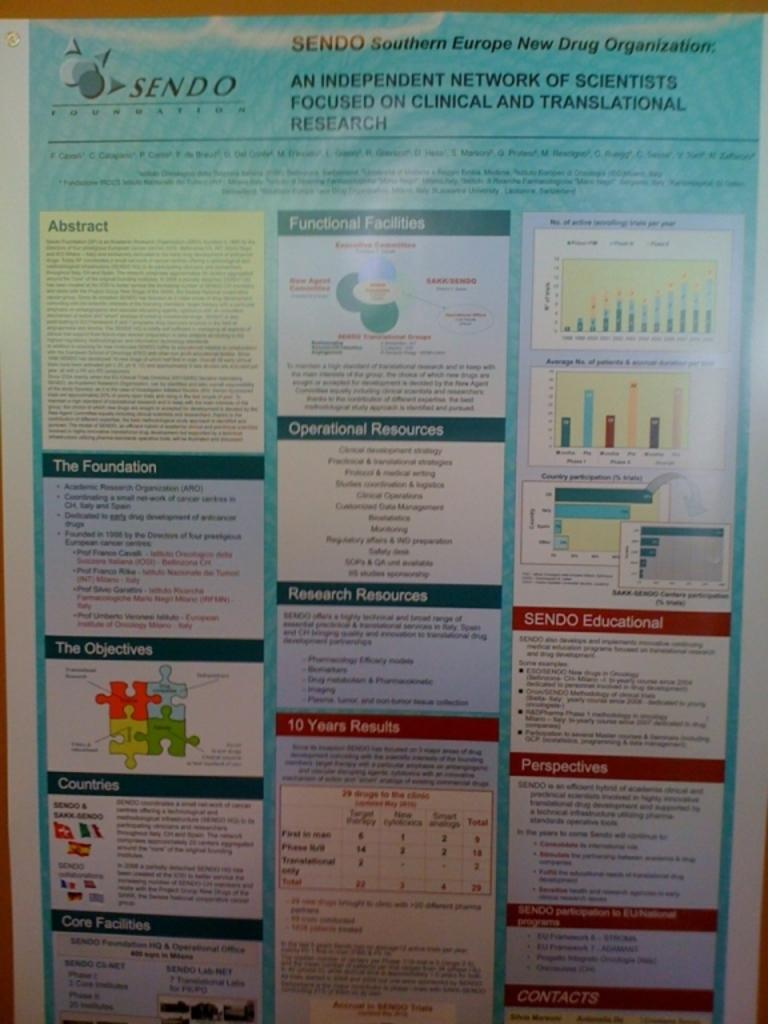Provide a one-sentence caption for the provided image. A poster for SENDO shows several facts and charts on it. 